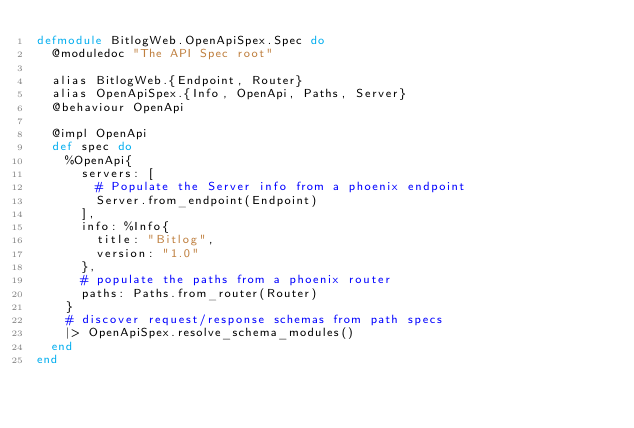<code> <loc_0><loc_0><loc_500><loc_500><_Elixir_>defmodule BitlogWeb.OpenApiSpex.Spec do
  @moduledoc "The API Spec root"

  alias BitlogWeb.{Endpoint, Router}
  alias OpenApiSpex.{Info, OpenApi, Paths, Server}
  @behaviour OpenApi

  @impl OpenApi
  def spec do
    %OpenApi{
      servers: [
        # Populate the Server info from a phoenix endpoint
        Server.from_endpoint(Endpoint)
      ],
      info: %Info{
        title: "Bitlog",
        version: "1.0"
      },
      # populate the paths from a phoenix router
      paths: Paths.from_router(Router)
    }
    # discover request/response schemas from path specs
    |> OpenApiSpex.resolve_schema_modules()
  end
end
</code> 